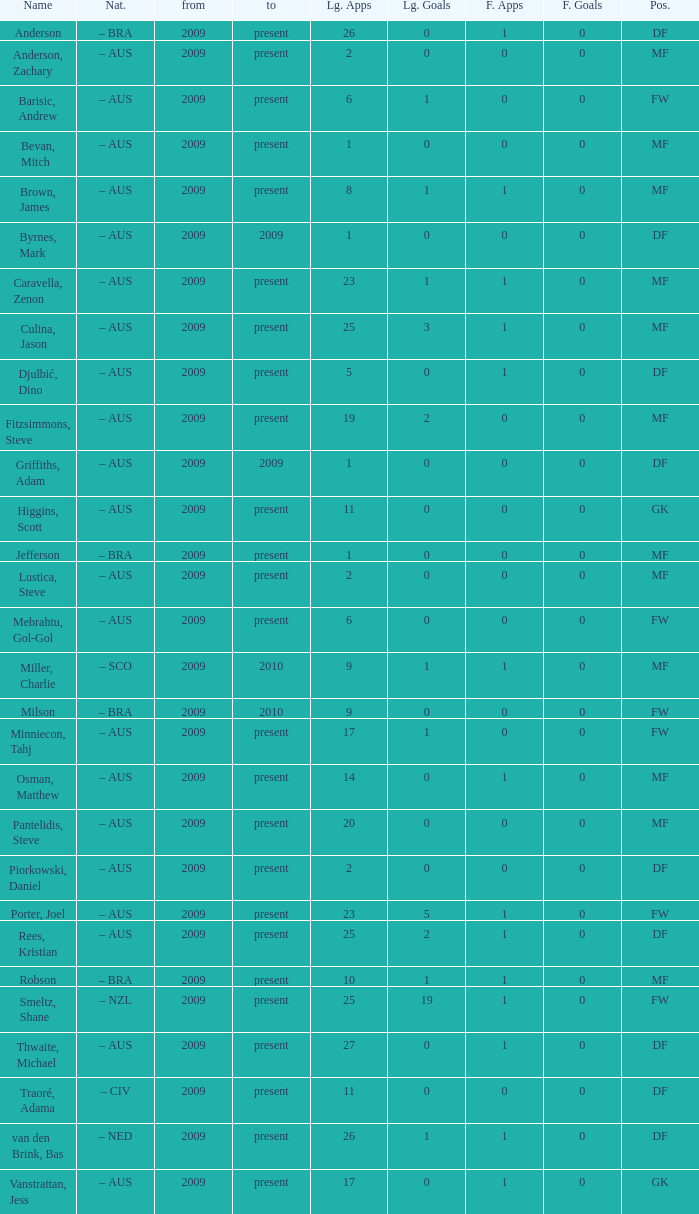What is the occupation of bas van den brink? DF. 